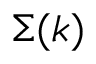<formula> <loc_0><loc_0><loc_500><loc_500>\Sigma ( k )</formula> 